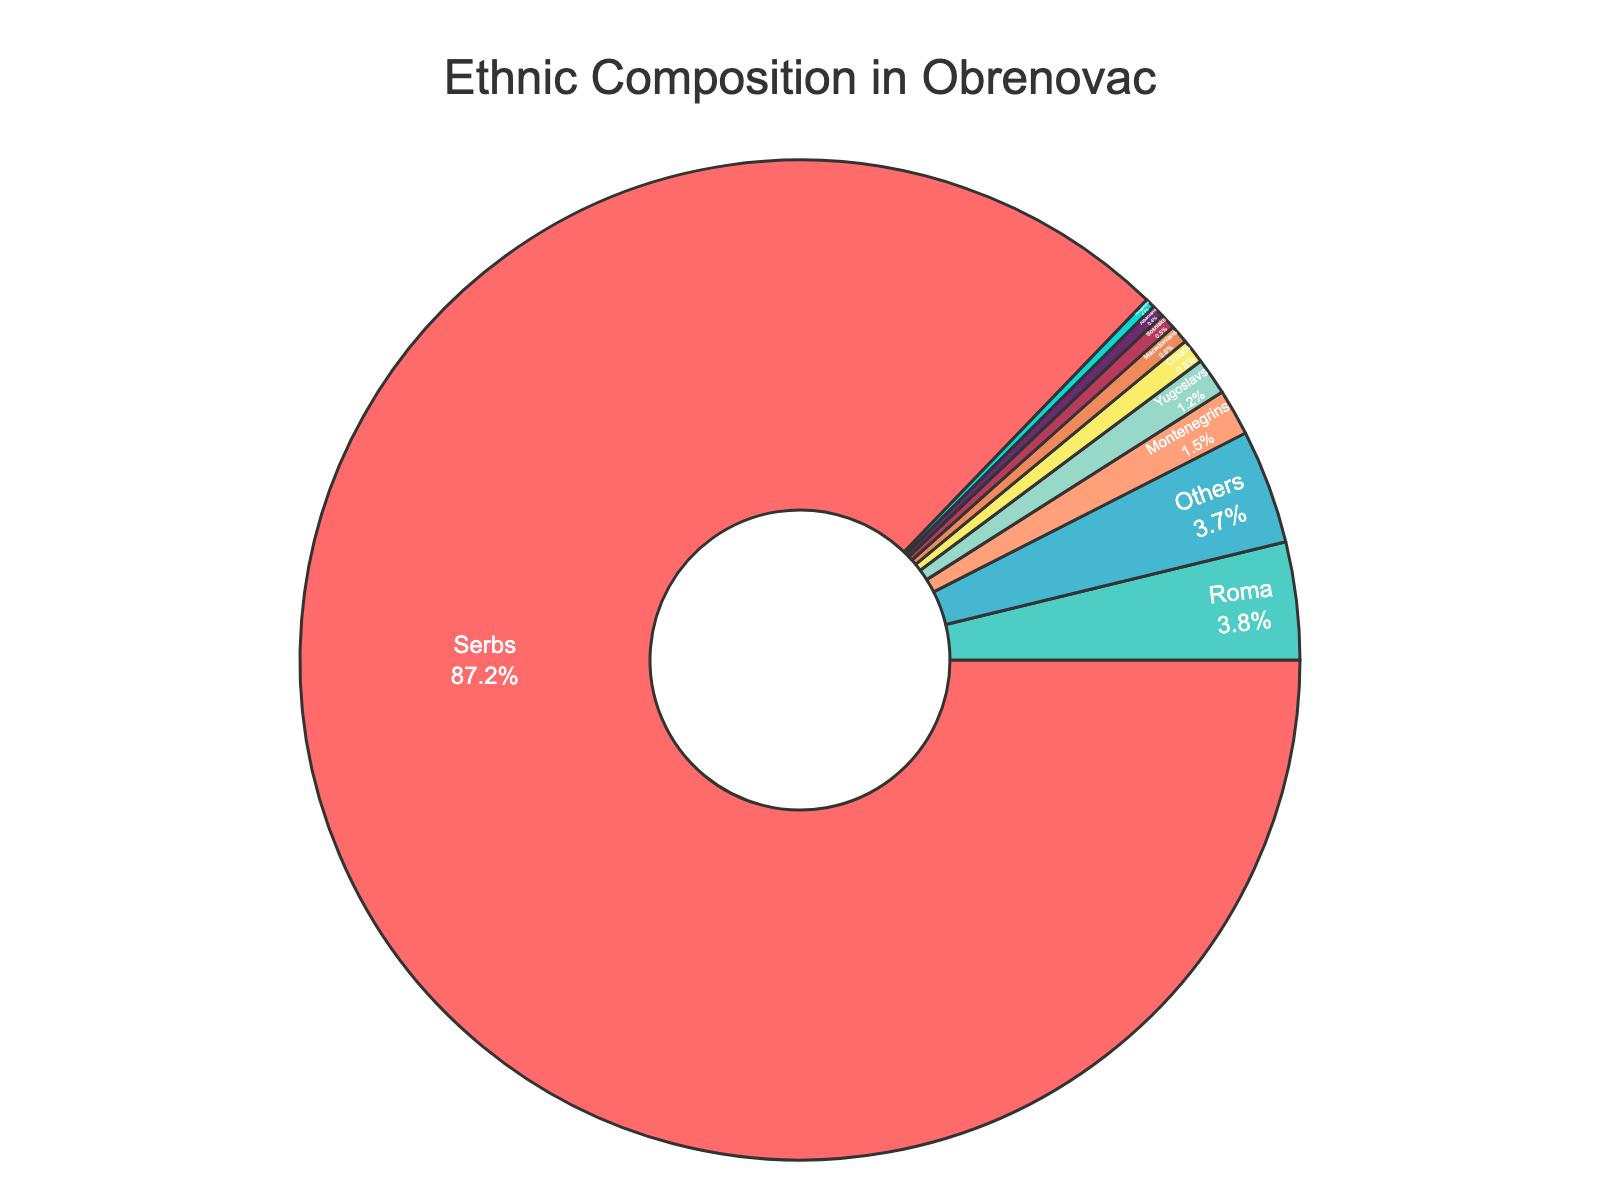What is the percentage of Serbs in Obrenovac's population? The figure shows the composition of ethnic groups in percentages. The percentage for Serbs can be directly seen.
Answer: 87.2% What is the sum of the percentages for the three largest ethnic groups in Obrenovac? The three largest ethnic groups are Serbs, Roma, and Montenegrins. Adding their percentages gives 87.2% + 3.8% + 1.5%.
Answer: 92.5% Which ethnic group has a slightly higher percentage, Roma or Montenegrins? Roma has 3.8% and Montenegrins have 1.5%. Comparing these two values, Roma has a higher percentage.
Answer: Roma What is the difference in the percentage between Serbs and Roma? The percentage of Serbs is 87.2% and that of Roma is 3.8%. Subtracting these gives 87.2% - 3.8%.
Answer: 83.4% How does the percentage of 'Others' compare to the percentage of Roma? The percentage for "Others" is 3.7% and for Roma is 3.8%. Comparing these values, Roma has a slightly higher percentage.
Answer: Roma Are there more Montenegrins or Macedonians in Obrenovac based on the percentage? Montenegrins have 1.5% and Macedonians have 0.6%. Montenegrins have a higher percentage.
Answer: Montenegrins What color is used to represent the largest ethnic group? The largest ethnic group, Serbs, is represented by the first color in the custom palette. The figure shows this color as red.
Answer: Red What is the combined percentage of Yugoslavs, Croats, and Bosniaks? Adding the percentages of Yugoslavs (1.2%), Croats (0.8%), and Bosniaks (0.5%) gives 1.2% + 0.8% + 0.5%.
Answer: 2.5% Which ethnic group is represented by a yellow slice in the pie chart? One of the colors in the custom palette is yellow, assigned in descending order of percentage. The figure indicates that Montenegrins are represented by this color.
Answer: Montenegrins What is the average percentage of Albanians, Hungarians, and "Others"? The percentages are Albanians (0.4%), Hungarians (0.3%), and "Others" (3.7%). Adding these gives 0.4% + 0.3% + 3.7% and dividing by 3.
Answer: 1.47% 